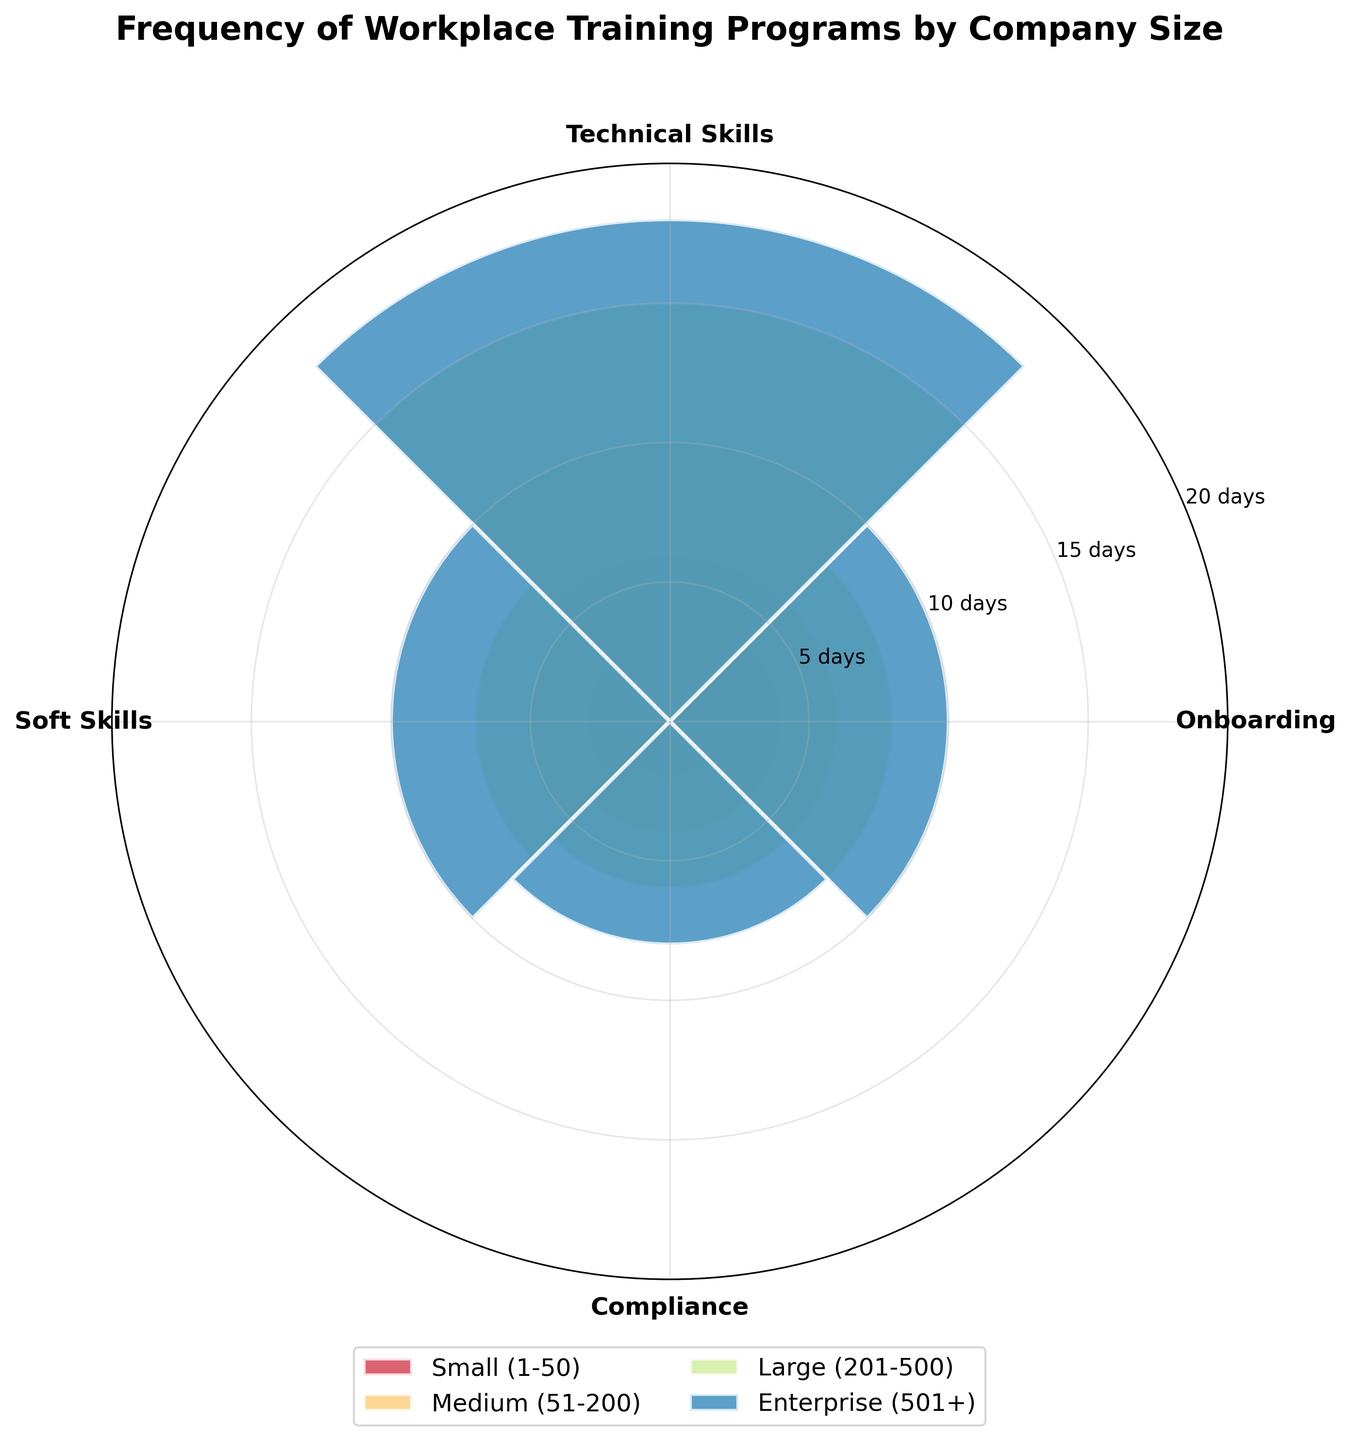What is the title of the chart? The title is typically located at the top of the figure. In this case, the title is "Frequency of Workplace Training Programs by Company Size" as explicitly stated.
Answer: Frequency of Workplace Training Programs by Company Size Which company size group has the highest frequency for Technical Skills training? To determine this, look at the bars for Technical Skills training across all company sizes. The Enterprise (501+) group has the highest value as indicated by the tallest bar in that category.
Answer: Enterprise (501+) How many days per year does the Medium (51-200) company size spend on Compliance training? Find the section of the rose chart corresponding to Medium (51-200) companies and locate the Compliance training. The bar for Compliance training is at 4 days per year.
Answer: 4 days per year Which training program has the lowest frequency in Small (1-50) companies? Look at the bars for all training programs in the Small (1-50) segment. The smallest bar is for Compliance training with 2 days per year.
Answer: Compliance For Enterprise (501+) companies, how many more days are spent on Technical Skills training compared to Soft Skills training? For Enterprise (501+), Technical Skills is 18 days and Soft Skills is 10 days. The difference is 18 - 10 = 8 days.
Answer: 8 days What is the total sum of training days per year across all training programs for Large (201-500) companies? Sum the days for all training programs within Large (201-500). Onboarding is 8, Technical Skills is 15, Soft Skills is 7, and Compliance is 6. Total: 8 + 15 + 7 + 6 = 36 days per year.
Answer: 36 days per year Which company size category spends the least amount of time on Onboarding training, and how many days is it? Compare the Onboarding training days across all company sizes. The Small (1-50) category spends the least time with 4 days.
Answer: Small (1-50) with 4 days How does the frequency of Soft Skills training change from Small (1-50) to Enterprise (501+)? Observe the Soft Skills training frequency for Small (1-50) and Enterprise (501+). Small (1-50) has 3 days, and Enterprise (501+) has 10 days.
Answer: Increases from 3 days to 10 days Which training program has the most consistent frequency across all company sizes? Examine which training program shows the least variation in days across company sizes. Soft Skills training values (3, 5, 7, 10) are fairly close compared to others.
Answer: Soft Skills 